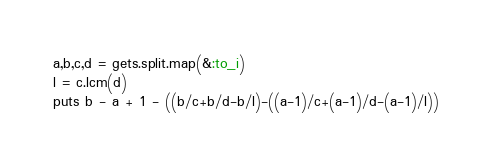Convert code to text. <code><loc_0><loc_0><loc_500><loc_500><_Ruby_>a,b,c,d = gets.split.map(&:to_i)
l = c.lcm(d)
puts b - a + 1 - ((b/c+b/d-b/l)-((a-1)/c+(a-1)/d-(a-1)/l))</code> 